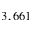Convert formula to latex. <formula><loc_0><loc_0><loc_500><loc_500>3 , 6 6 1</formula> 